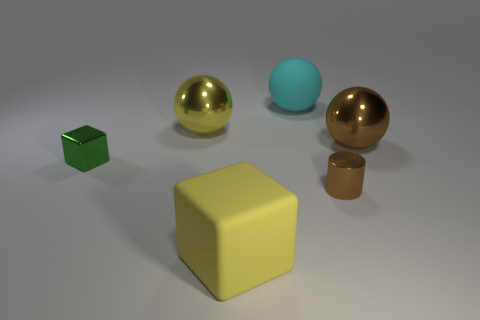How big is the metallic cylinder?
Give a very brief answer. Small. What number of cubes are either yellow objects or cyan objects?
Provide a short and direct response. 1. What is the size of the brown sphere that is the same material as the tiny block?
Ensure brevity in your answer.  Large. How many shiny things are the same color as the large cube?
Give a very brief answer. 1. There is a big rubber sphere; are there any rubber objects to the left of it?
Your answer should be compact. Yes. There is a large yellow metallic object; is it the same shape as the tiny object on the left side of the large matte ball?
Provide a short and direct response. No. How many objects are large things that are right of the small brown metallic cylinder or big cyan matte things?
Your answer should be compact. 2. Is there any other thing that is the same material as the cyan object?
Provide a short and direct response. Yes. How many things are right of the big yellow metallic object and in front of the yellow metal ball?
Provide a short and direct response. 3. How many objects are large spheres that are right of the large cyan rubber ball or spheres behind the large brown ball?
Provide a short and direct response. 3. 